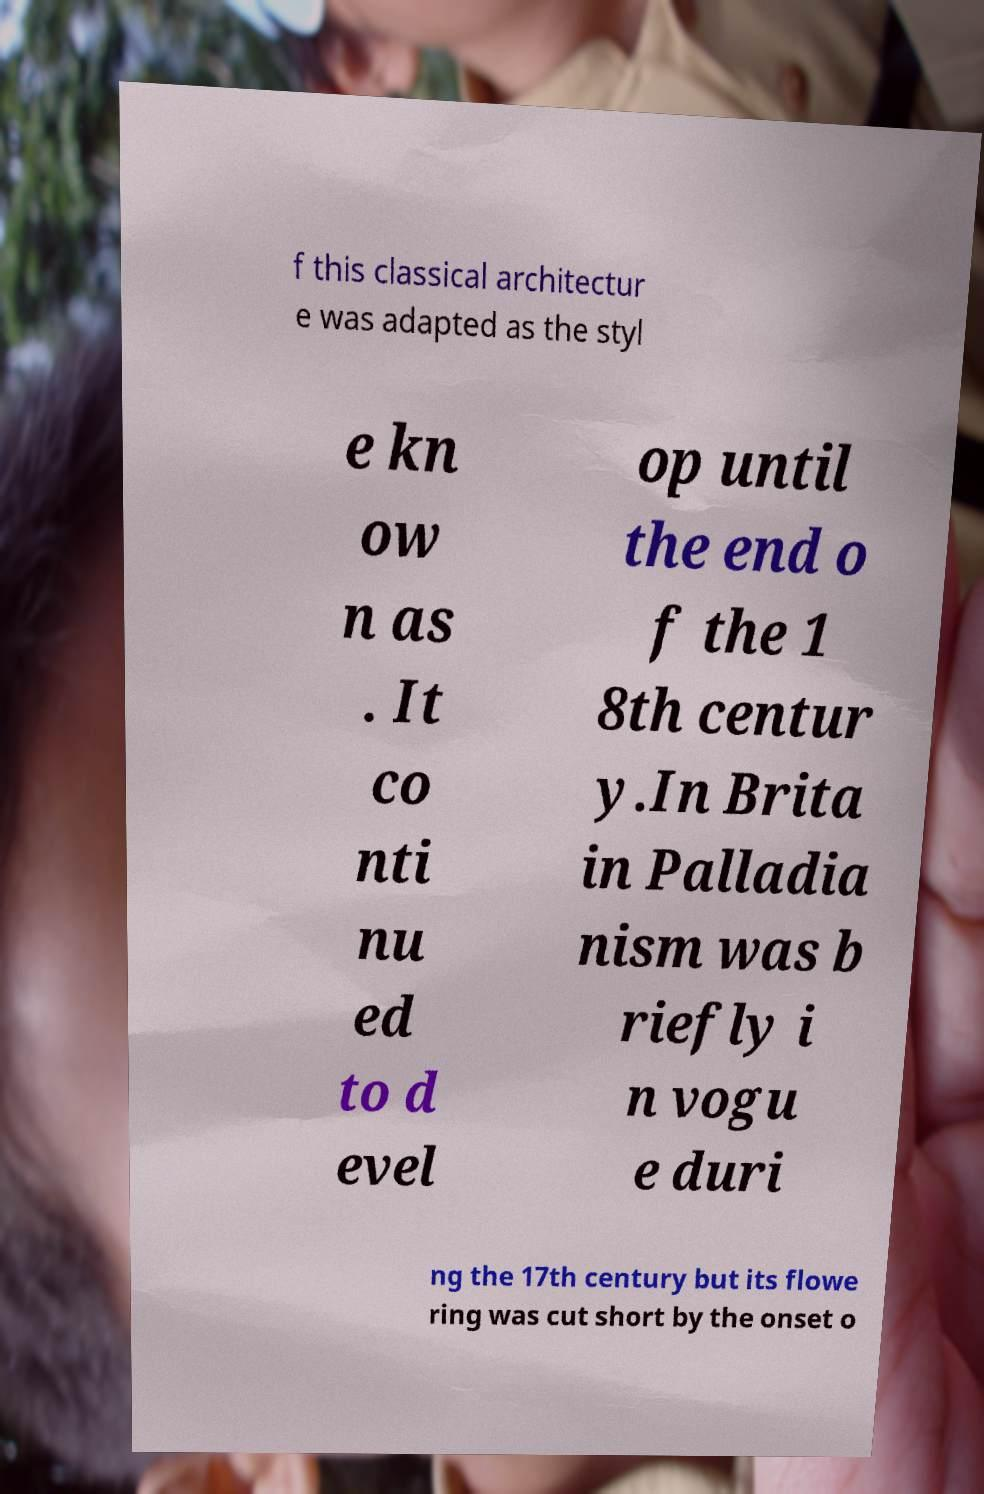There's text embedded in this image that I need extracted. Can you transcribe it verbatim? f this classical architectur e was adapted as the styl e kn ow n as . It co nti nu ed to d evel op until the end o f the 1 8th centur y.In Brita in Palladia nism was b riefly i n vogu e duri ng the 17th century but its flowe ring was cut short by the onset o 